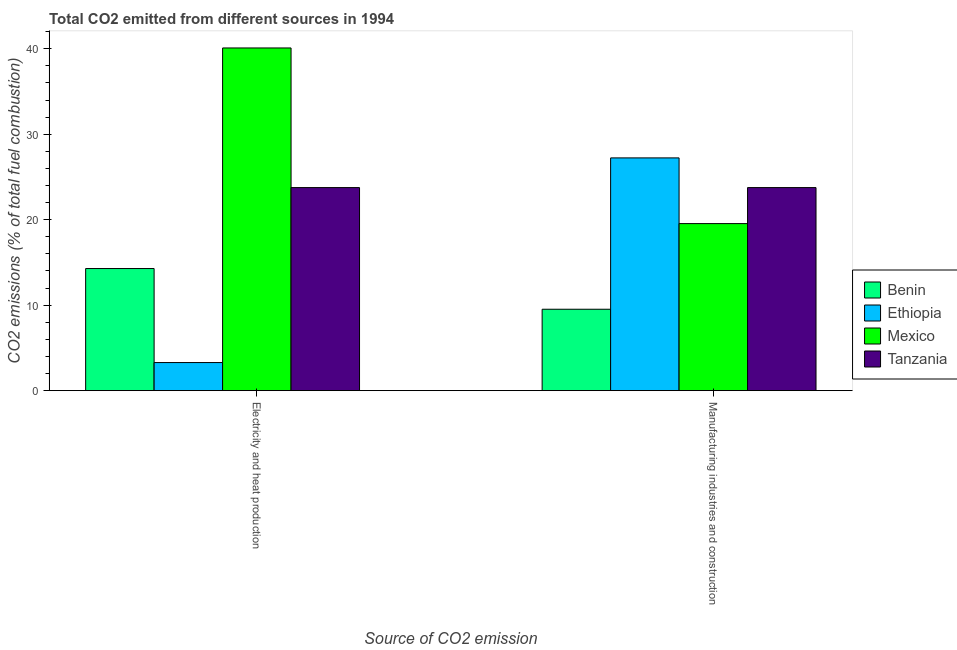How many different coloured bars are there?
Provide a short and direct response. 4. How many groups of bars are there?
Keep it short and to the point. 2. Are the number of bars per tick equal to the number of legend labels?
Provide a short and direct response. Yes. How many bars are there on the 1st tick from the right?
Offer a very short reply. 4. What is the label of the 2nd group of bars from the left?
Make the answer very short. Manufacturing industries and construction. What is the co2 emissions due to electricity and heat production in Benin?
Keep it short and to the point. 14.29. Across all countries, what is the maximum co2 emissions due to manufacturing industries?
Offer a very short reply. 27.23. Across all countries, what is the minimum co2 emissions due to manufacturing industries?
Your response must be concise. 9.52. In which country was the co2 emissions due to manufacturing industries maximum?
Provide a succinct answer. Ethiopia. In which country was the co2 emissions due to electricity and heat production minimum?
Keep it short and to the point. Ethiopia. What is the total co2 emissions due to manufacturing industries in the graph?
Offer a very short reply. 80.05. What is the difference between the co2 emissions due to manufacturing industries in Tanzania and that in Mexico?
Make the answer very short. 4.21. What is the difference between the co2 emissions due to electricity and heat production in Benin and the co2 emissions due to manufacturing industries in Ethiopia?
Make the answer very short. -12.94. What is the average co2 emissions due to electricity and heat production per country?
Offer a terse response. 20.36. What is the difference between the co2 emissions due to manufacturing industries and co2 emissions due to electricity and heat production in Ethiopia?
Give a very brief answer. 23.94. What is the ratio of the co2 emissions due to manufacturing industries in Tanzania to that in Ethiopia?
Your answer should be very brief. 0.87. What does the 2nd bar from the left in Electricity and heat production represents?
Your answer should be very brief. Ethiopia. What does the 3rd bar from the right in Electricity and heat production represents?
Provide a succinct answer. Ethiopia. Are all the bars in the graph horizontal?
Provide a succinct answer. No. How many countries are there in the graph?
Your answer should be very brief. 4. What is the difference between two consecutive major ticks on the Y-axis?
Ensure brevity in your answer.  10. Does the graph contain any zero values?
Your answer should be compact. No. How many legend labels are there?
Provide a succinct answer. 4. What is the title of the graph?
Your response must be concise. Total CO2 emitted from different sources in 1994. What is the label or title of the X-axis?
Provide a short and direct response. Source of CO2 emission. What is the label or title of the Y-axis?
Your answer should be very brief. CO2 emissions (% of total fuel combustion). What is the CO2 emissions (% of total fuel combustion) in Benin in Electricity and heat production?
Ensure brevity in your answer.  14.29. What is the CO2 emissions (% of total fuel combustion) of Ethiopia in Electricity and heat production?
Your response must be concise. 3.29. What is the CO2 emissions (% of total fuel combustion) of Mexico in Electricity and heat production?
Your answer should be compact. 40.09. What is the CO2 emissions (% of total fuel combustion) of Tanzania in Electricity and heat production?
Provide a succinct answer. 23.76. What is the CO2 emissions (% of total fuel combustion) of Benin in Manufacturing industries and construction?
Your response must be concise. 9.52. What is the CO2 emissions (% of total fuel combustion) in Ethiopia in Manufacturing industries and construction?
Give a very brief answer. 27.23. What is the CO2 emissions (% of total fuel combustion) in Mexico in Manufacturing industries and construction?
Keep it short and to the point. 19.54. What is the CO2 emissions (% of total fuel combustion) of Tanzania in Manufacturing industries and construction?
Your answer should be compact. 23.76. Across all Source of CO2 emission, what is the maximum CO2 emissions (% of total fuel combustion) in Benin?
Offer a terse response. 14.29. Across all Source of CO2 emission, what is the maximum CO2 emissions (% of total fuel combustion) of Ethiopia?
Make the answer very short. 27.23. Across all Source of CO2 emission, what is the maximum CO2 emissions (% of total fuel combustion) in Mexico?
Keep it short and to the point. 40.09. Across all Source of CO2 emission, what is the maximum CO2 emissions (% of total fuel combustion) in Tanzania?
Make the answer very short. 23.76. Across all Source of CO2 emission, what is the minimum CO2 emissions (% of total fuel combustion) in Benin?
Offer a terse response. 9.52. Across all Source of CO2 emission, what is the minimum CO2 emissions (% of total fuel combustion) of Ethiopia?
Provide a short and direct response. 3.29. Across all Source of CO2 emission, what is the minimum CO2 emissions (% of total fuel combustion) of Mexico?
Your answer should be compact. 19.54. Across all Source of CO2 emission, what is the minimum CO2 emissions (% of total fuel combustion) of Tanzania?
Provide a succinct answer. 23.76. What is the total CO2 emissions (% of total fuel combustion) of Benin in the graph?
Your answer should be very brief. 23.81. What is the total CO2 emissions (% of total fuel combustion) in Ethiopia in the graph?
Your answer should be compact. 30.52. What is the total CO2 emissions (% of total fuel combustion) in Mexico in the graph?
Offer a very short reply. 59.64. What is the total CO2 emissions (% of total fuel combustion) in Tanzania in the graph?
Provide a succinct answer. 47.51. What is the difference between the CO2 emissions (% of total fuel combustion) of Benin in Electricity and heat production and that in Manufacturing industries and construction?
Ensure brevity in your answer.  4.76. What is the difference between the CO2 emissions (% of total fuel combustion) of Ethiopia in Electricity and heat production and that in Manufacturing industries and construction?
Make the answer very short. -23.94. What is the difference between the CO2 emissions (% of total fuel combustion) in Mexico in Electricity and heat production and that in Manufacturing industries and construction?
Your response must be concise. 20.55. What is the difference between the CO2 emissions (% of total fuel combustion) of Tanzania in Electricity and heat production and that in Manufacturing industries and construction?
Provide a short and direct response. 0. What is the difference between the CO2 emissions (% of total fuel combustion) in Benin in Electricity and heat production and the CO2 emissions (% of total fuel combustion) in Ethiopia in Manufacturing industries and construction?
Offer a very short reply. -12.94. What is the difference between the CO2 emissions (% of total fuel combustion) of Benin in Electricity and heat production and the CO2 emissions (% of total fuel combustion) of Mexico in Manufacturing industries and construction?
Keep it short and to the point. -5.26. What is the difference between the CO2 emissions (% of total fuel combustion) in Benin in Electricity and heat production and the CO2 emissions (% of total fuel combustion) in Tanzania in Manufacturing industries and construction?
Your answer should be very brief. -9.47. What is the difference between the CO2 emissions (% of total fuel combustion) in Ethiopia in Electricity and heat production and the CO2 emissions (% of total fuel combustion) in Mexico in Manufacturing industries and construction?
Provide a short and direct response. -16.26. What is the difference between the CO2 emissions (% of total fuel combustion) of Ethiopia in Electricity and heat production and the CO2 emissions (% of total fuel combustion) of Tanzania in Manufacturing industries and construction?
Your answer should be compact. -20.47. What is the difference between the CO2 emissions (% of total fuel combustion) of Mexico in Electricity and heat production and the CO2 emissions (% of total fuel combustion) of Tanzania in Manufacturing industries and construction?
Provide a succinct answer. 16.34. What is the average CO2 emissions (% of total fuel combustion) of Benin per Source of CO2 emission?
Ensure brevity in your answer.  11.9. What is the average CO2 emissions (% of total fuel combustion) of Ethiopia per Source of CO2 emission?
Offer a terse response. 15.26. What is the average CO2 emissions (% of total fuel combustion) of Mexico per Source of CO2 emission?
Ensure brevity in your answer.  29.82. What is the average CO2 emissions (% of total fuel combustion) of Tanzania per Source of CO2 emission?
Give a very brief answer. 23.76. What is the difference between the CO2 emissions (% of total fuel combustion) of Benin and CO2 emissions (% of total fuel combustion) of Ethiopia in Electricity and heat production?
Your answer should be very brief. 11. What is the difference between the CO2 emissions (% of total fuel combustion) in Benin and CO2 emissions (% of total fuel combustion) in Mexico in Electricity and heat production?
Keep it short and to the point. -25.81. What is the difference between the CO2 emissions (% of total fuel combustion) of Benin and CO2 emissions (% of total fuel combustion) of Tanzania in Electricity and heat production?
Offer a very short reply. -9.47. What is the difference between the CO2 emissions (% of total fuel combustion) in Ethiopia and CO2 emissions (% of total fuel combustion) in Mexico in Electricity and heat production?
Make the answer very short. -36.81. What is the difference between the CO2 emissions (% of total fuel combustion) in Ethiopia and CO2 emissions (% of total fuel combustion) in Tanzania in Electricity and heat production?
Make the answer very short. -20.47. What is the difference between the CO2 emissions (% of total fuel combustion) of Mexico and CO2 emissions (% of total fuel combustion) of Tanzania in Electricity and heat production?
Offer a very short reply. 16.34. What is the difference between the CO2 emissions (% of total fuel combustion) of Benin and CO2 emissions (% of total fuel combustion) of Ethiopia in Manufacturing industries and construction?
Keep it short and to the point. -17.71. What is the difference between the CO2 emissions (% of total fuel combustion) of Benin and CO2 emissions (% of total fuel combustion) of Mexico in Manufacturing industries and construction?
Make the answer very short. -10.02. What is the difference between the CO2 emissions (% of total fuel combustion) in Benin and CO2 emissions (% of total fuel combustion) in Tanzania in Manufacturing industries and construction?
Offer a terse response. -14.23. What is the difference between the CO2 emissions (% of total fuel combustion) in Ethiopia and CO2 emissions (% of total fuel combustion) in Mexico in Manufacturing industries and construction?
Keep it short and to the point. 7.69. What is the difference between the CO2 emissions (% of total fuel combustion) of Ethiopia and CO2 emissions (% of total fuel combustion) of Tanzania in Manufacturing industries and construction?
Give a very brief answer. 3.47. What is the difference between the CO2 emissions (% of total fuel combustion) of Mexico and CO2 emissions (% of total fuel combustion) of Tanzania in Manufacturing industries and construction?
Give a very brief answer. -4.21. What is the ratio of the CO2 emissions (% of total fuel combustion) of Ethiopia in Electricity and heat production to that in Manufacturing industries and construction?
Give a very brief answer. 0.12. What is the ratio of the CO2 emissions (% of total fuel combustion) of Mexico in Electricity and heat production to that in Manufacturing industries and construction?
Keep it short and to the point. 2.05. What is the ratio of the CO2 emissions (% of total fuel combustion) in Tanzania in Electricity and heat production to that in Manufacturing industries and construction?
Ensure brevity in your answer.  1. What is the difference between the highest and the second highest CO2 emissions (% of total fuel combustion) of Benin?
Provide a succinct answer. 4.76. What is the difference between the highest and the second highest CO2 emissions (% of total fuel combustion) in Ethiopia?
Your response must be concise. 23.94. What is the difference between the highest and the second highest CO2 emissions (% of total fuel combustion) of Mexico?
Ensure brevity in your answer.  20.55. What is the difference between the highest and the lowest CO2 emissions (% of total fuel combustion) of Benin?
Ensure brevity in your answer.  4.76. What is the difference between the highest and the lowest CO2 emissions (% of total fuel combustion) of Ethiopia?
Provide a short and direct response. 23.94. What is the difference between the highest and the lowest CO2 emissions (% of total fuel combustion) of Mexico?
Your answer should be very brief. 20.55. What is the difference between the highest and the lowest CO2 emissions (% of total fuel combustion) in Tanzania?
Provide a succinct answer. 0. 